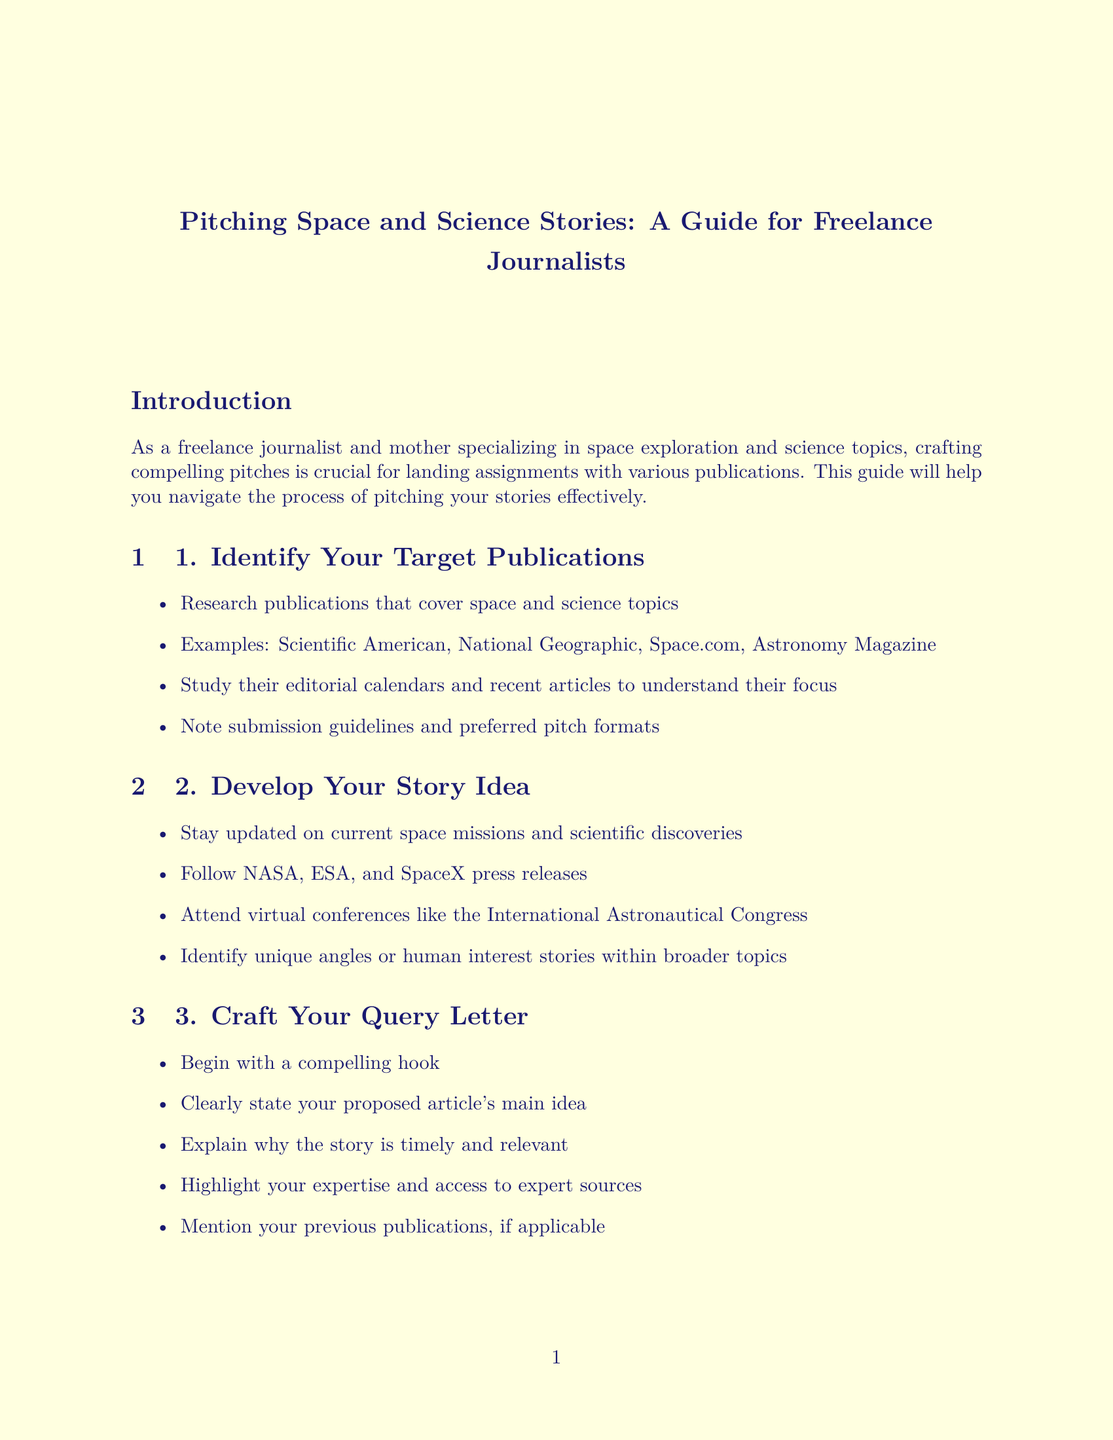What are the sample query letters for? The sample query letters are provided as examples to guide freelance journalists in crafting their own pitches for specific publications.
Answer: Feature and news articles How many words is the suggested word count for the articles? The manual suggests a specific word count range for pitches, indicating a standard length for freelance submissions.
Answer: 300-500 words Which publication is cited for a timely article about the ExoMars rover? The specific publication is highlighted within the context of the proposed article about the ExoMars rover focusing on software updates.
Answer: Space.com Name one organization to follow for current space missions and discoveries. This question asks for an example of an organization that provides updates on space exploration activities.
Answer: NASA What is a key point to include in a query letter? The manual outlines certain elements that should be included in a query letter to be effective, focusing on essential information necessary for the editor.
Answer: A compelling hook When should you follow up on your pitch? The timeline for following up is specified to help journalists manage their submission processes effectively.
Answer: 1-2 weeks What should you include in your pitch's subject line? This is directed towards the specifics of what to feature in the subject line when sending a pitch, which is an important part of email communication with editors.
Answer: A strong subject line Who is an example of a key source mentioned in the first sample query letter? The question seeks to identify an expert highlighted as a potential interview source in the example letter.
Answer: Dr. Karen Nyberg What perspective should you highlight in your pitch? This question asks about a particular angle or unique viewpoint a freelance journalist should emphasize in their story proposals.
Answer: Your unique perspective as a mother 